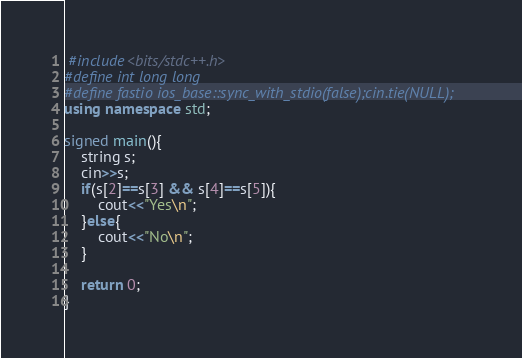Convert code to text. <code><loc_0><loc_0><loc_500><loc_500><_C++_> #include<bits/stdc++.h>
#define int long long
#define fastio ios_base::sync_with_stdio(false);cin.tie(NULL);
using namespace std;

signed main(){
    string s;
    cin>>s;
    if(s[2]==s[3] && s[4]==s[5]){
        cout<<"Yes\n";
    }else{
        cout<<"No\n";
    }

    return 0;
}</code> 